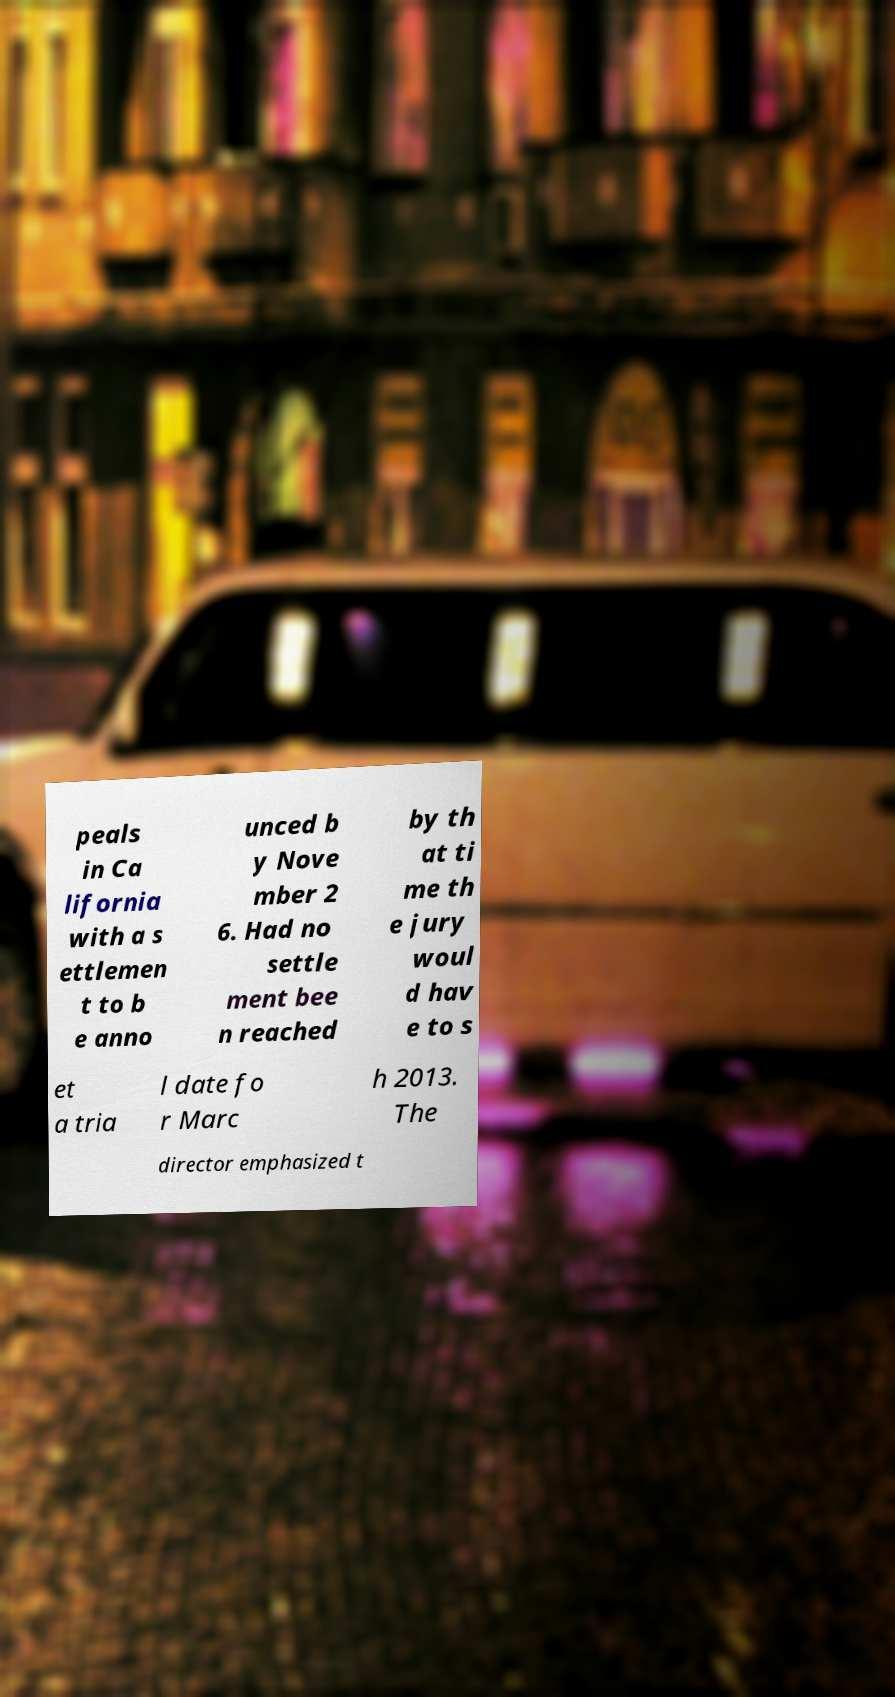Please read and relay the text visible in this image. What does it say? peals in Ca lifornia with a s ettlemen t to b e anno unced b y Nove mber 2 6. Had no settle ment bee n reached by th at ti me th e jury woul d hav e to s et a tria l date fo r Marc h 2013. The director emphasized t 